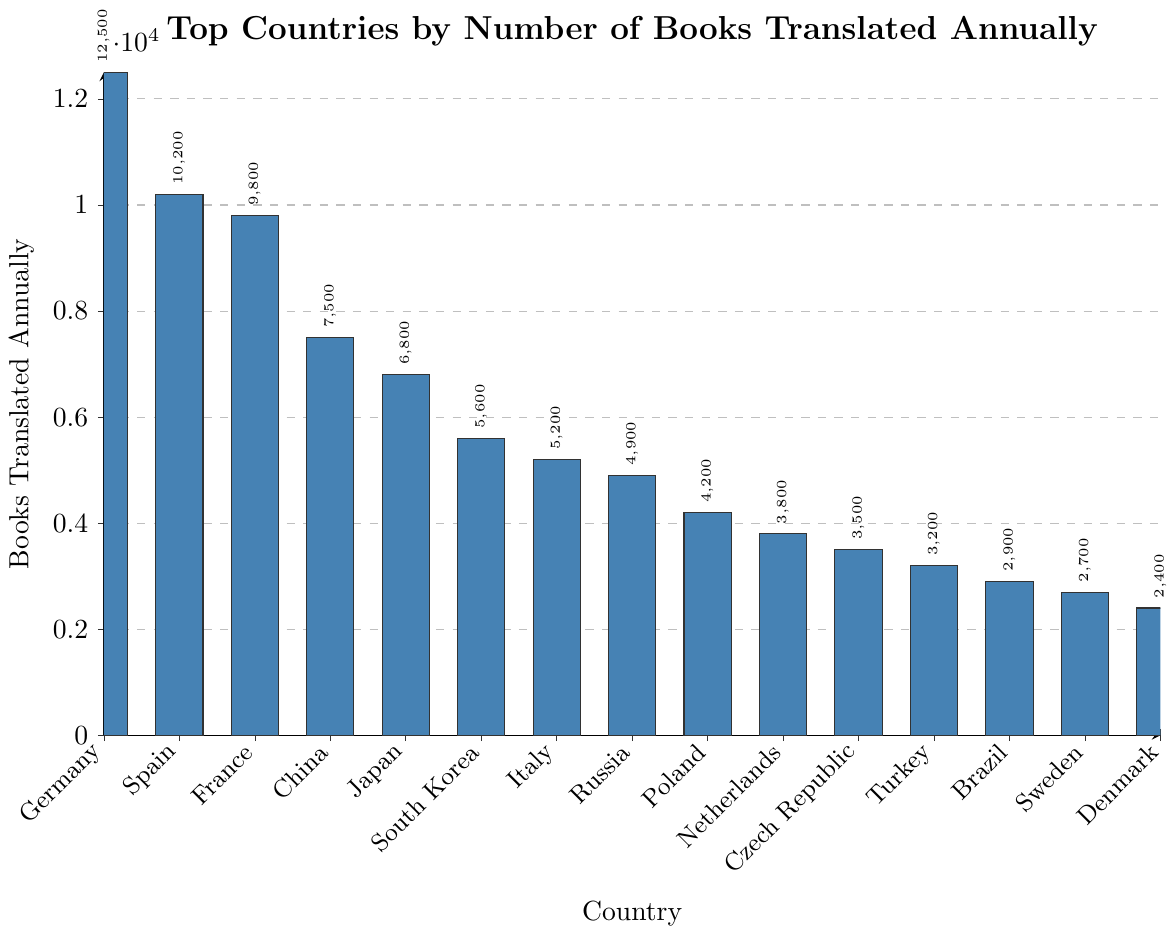What's the country with the highest number of books translated annually? The highest bar in the chart represents Germany, indicating it has the highest number of books translated annually.
Answer: Germany Which two countries have the closest number of books translated annually, and what are their values? Comparing the heights of the bars, Spain and France have the closest number of books translated, with Spain having 10,200 books and France having 9,800 books.
Answer: Spain (10,200) and France (9,800) How many more books are translated annually in Germany compared to Italy? Germany translates 12,500 books annually, and Italy translates 5,200 books. The difference between them is 12,500 - 5,200 = 7,300.
Answer: 7,300 What is the combined total of books translated annually by the top three countries? The top three countries are Germany (12,500), Spain (10,200), and France (9,800). The combined total is 12,500 + 10,200 + 9,800 = 32,500.
Answer: 32,500 Which countries have less than 5,000 books translated annually? The bars representing Russia, Poland, Netherlands, Czech Republic, Turkey, Brazil, Sweden, and Denmark are below the 5,000 mark.
Answer: Russia, Poland, Netherlands, Czech Republic, Turkey, Brazil, Sweden, Denmark Is the difference in the number of books translated annually between Japan and South Korea less than the difference between China and Japan? Japan translates 6,800 books and South Korea 5,600, so their difference is 6,800 - 5,600 = 1,200. China translates 7,500 books and Japan 6,800, so their difference is 7,500 - 6,800 = 700. The difference between China and Japan (700) is smaller than the difference between Japan and South Korea (1,200).
Answer: No What is the average number of books translated annually for the top 5 countries? The top 5 countries are Germany (12,500), Spain (10,200), France (9,800), China (7,500), and Japan (6,800). The sum of books is 12,500 + 10,200 + 9,800 + 7,500 + 6,800 = 46,800. The average is 46,800 / 5 = 9,360.
Answer: 9,360 Considering only the top 3 and bottom 3 countries by number of books translated annually, what is their total number of books translated? The top 3 countries are Germany (12,500), Spain (10,200), and France (9,800). The bottom 3 countries are Sweden (2,700), Denmark (2,400), and Brazil (2,900). The total is 12,500 + 10,200 + 9,800 + 2,700 + 2,400 + 2,900 = 40,500.
Answer: 40,500 How many countries translate more than 5,000 books annually? The bars for Germany, Spain, France, China, Japan, and South Korea are all above the 5,000 mark, which makes a total of 6 countries.
Answer: 6 Which color is used to represent the bars in the chart? All the bars in the chart are filled with the same shade of blue.
Answer: Blue 